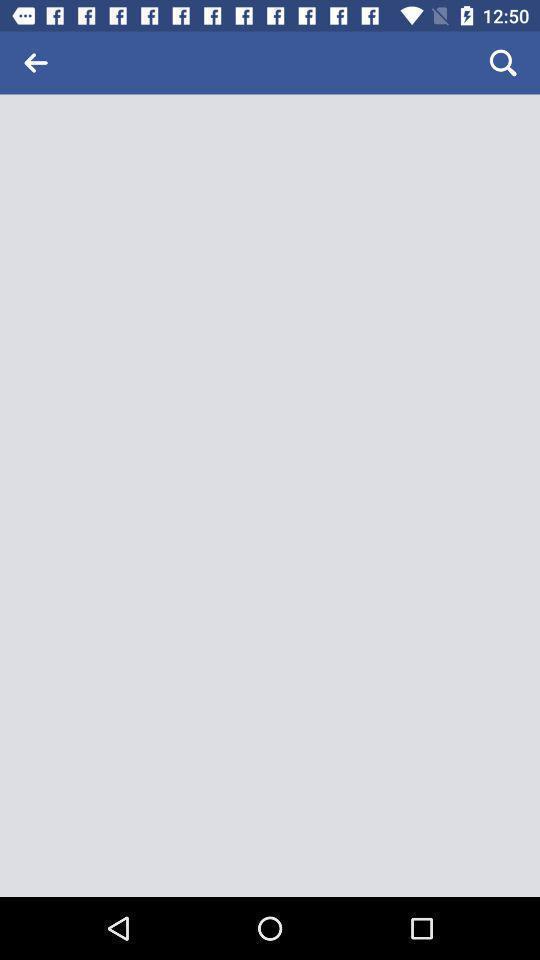Summarize the main components in this picture. Wight page of a social app. 